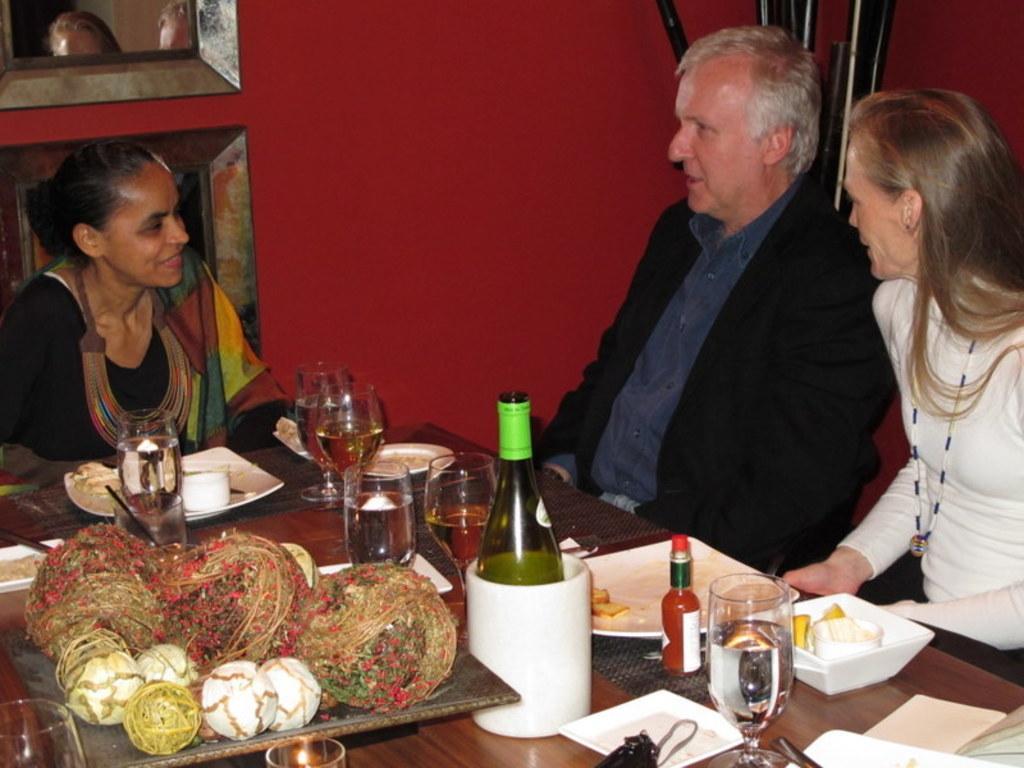How would you summarize this image in a sentence or two? In this image we can see three persons sitting. In the foreground we can see group of glasses, bottles, candle, spoons and a plate containing food are placed on the table. On the left side of the image we can see photo frames. In the background, we can see some pipes. 